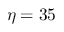<formula> <loc_0><loc_0><loc_500><loc_500>\eta = 3 5</formula> 